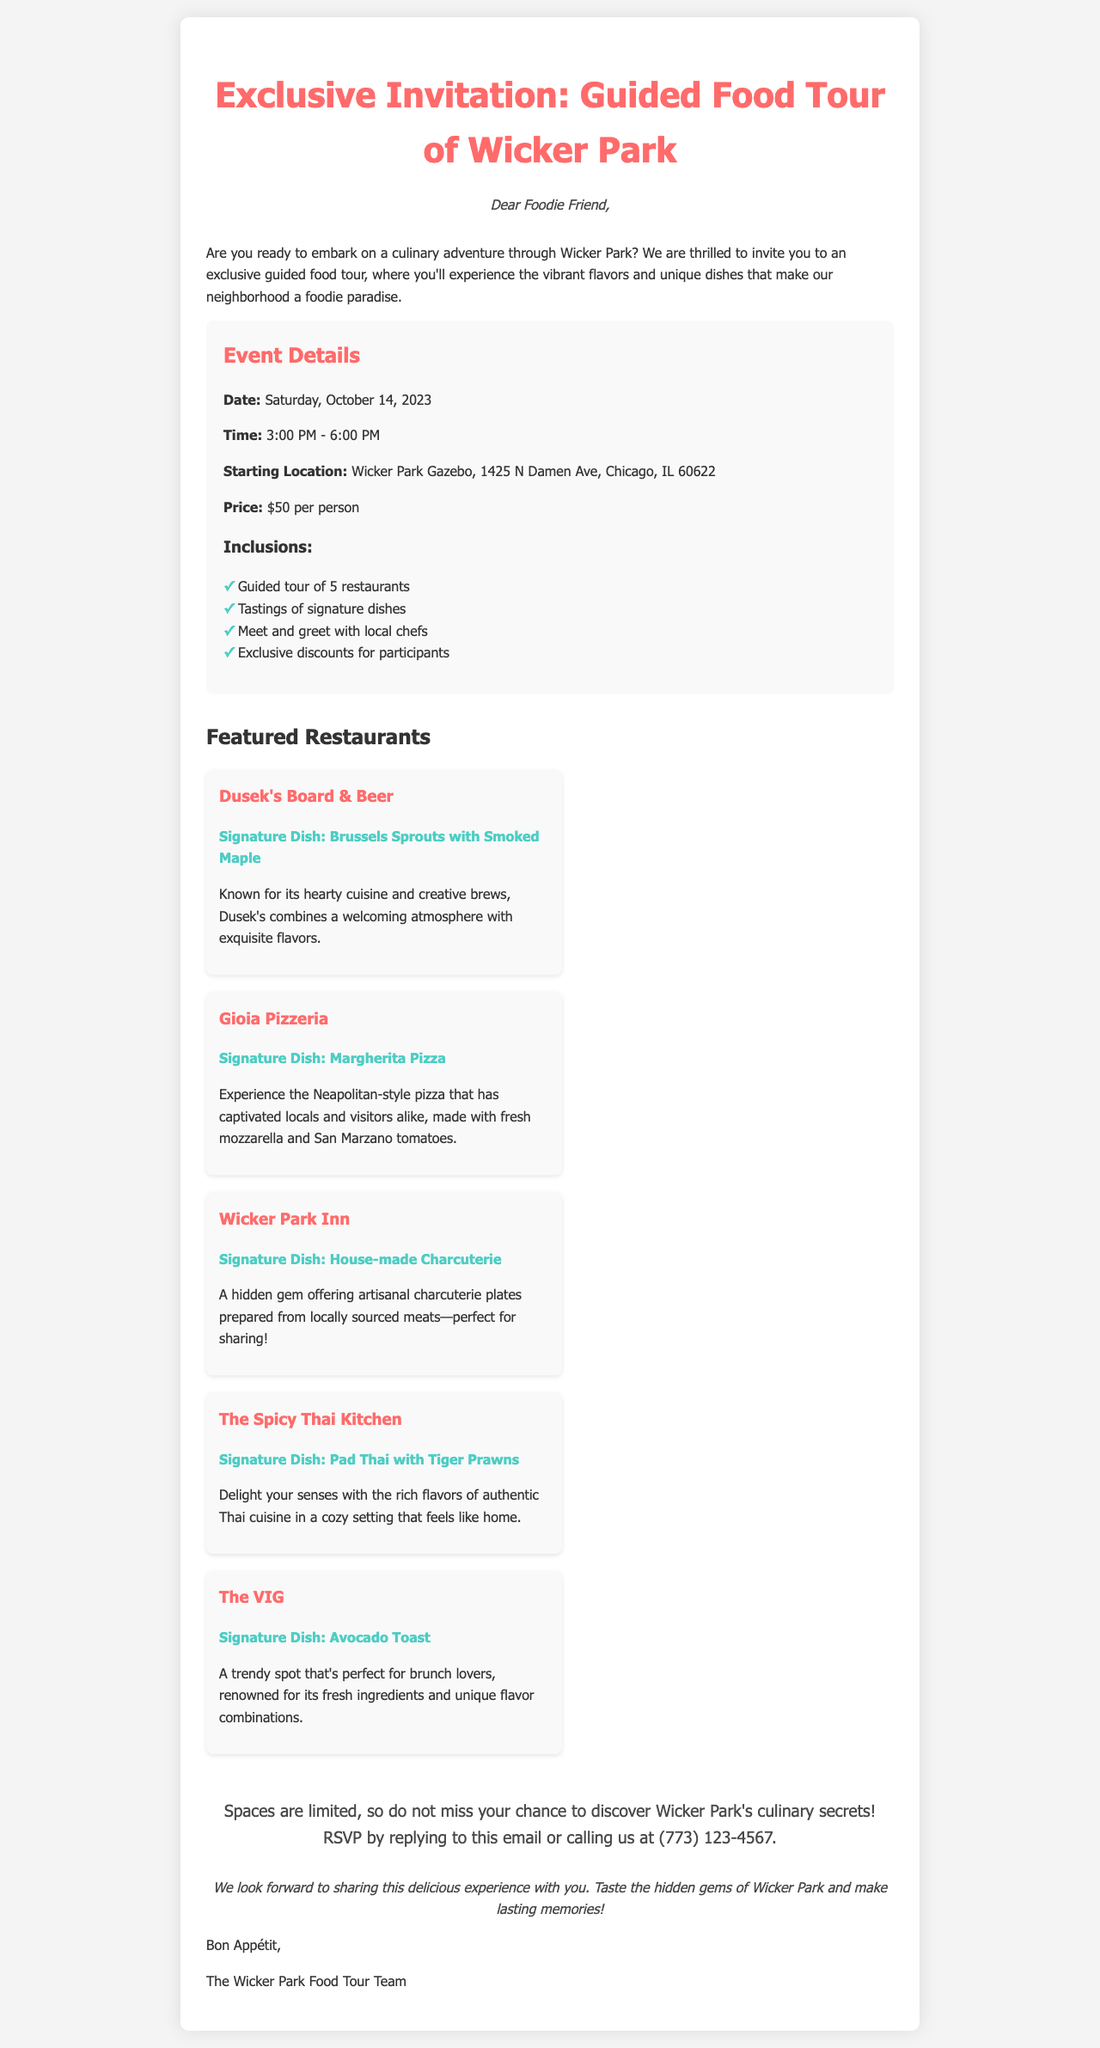What is the date of the food tour? The date of the food tour is specifically mentioned in the document as Saturday, October 14, 2023.
Answer: Saturday, October 14, 2023 What is the starting location of the tour? The starting location is indicated in the document as Wicker Park Gazebo, 1425 N Damen Ave, Chicago, IL 60622.
Answer: Wicker Park Gazebo, 1425 N Damen Ave, Chicago, IL 60622 How much does the tour cost per person? The price per person is clearly stated in the document as $50.
Answer: $50 Which restaurant serves Brussels Sprouts with Smoked Maple? The document lists Dusek's Board & Beer as the restaurant with this signature dish.
Answer: Dusek's Board & Beer What are participants encouraged to do to RSVP? The document advises participants to RSVP by replying to the email or calling a specific phone number.
Answer: Reply to this email or call us at (773) 123-4567 How many restaurants will be visited during the tour? The document indicates that the guided tour will include a visit to 5 restaurants.
Answer: 5 restaurants What type of cuisine is The Spicy Thai Kitchen known for? The document specifies that The Spicy Thai Kitchen is known for authentic Thai cuisine.
Answer: Authentic Thai cuisine What can participants expect to receive in terms of exclusive perks? The document mentions that participants will receive exclusive discounts as one of the inclusions.
Answer: Exclusive discounts 